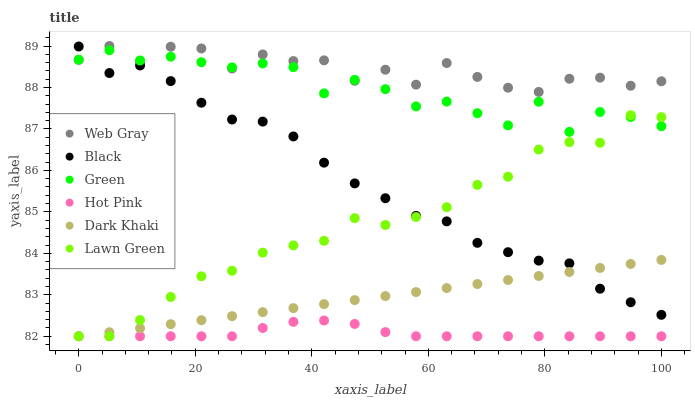Does Hot Pink have the minimum area under the curve?
Answer yes or no. Yes. Does Web Gray have the maximum area under the curve?
Answer yes or no. Yes. Does Web Gray have the minimum area under the curve?
Answer yes or no. No. Does Hot Pink have the maximum area under the curve?
Answer yes or no. No. Is Dark Khaki the smoothest?
Answer yes or no. Yes. Is Web Gray the roughest?
Answer yes or no. Yes. Is Hot Pink the smoothest?
Answer yes or no. No. Is Hot Pink the roughest?
Answer yes or no. No. Does Lawn Green have the lowest value?
Answer yes or no. Yes. Does Web Gray have the lowest value?
Answer yes or no. No. Does Web Gray have the highest value?
Answer yes or no. Yes. Does Hot Pink have the highest value?
Answer yes or no. No. Is Dark Khaki less than Green?
Answer yes or no. Yes. Is Green greater than Dark Khaki?
Answer yes or no. Yes. Does Dark Khaki intersect Black?
Answer yes or no. Yes. Is Dark Khaki less than Black?
Answer yes or no. No. Is Dark Khaki greater than Black?
Answer yes or no. No. Does Dark Khaki intersect Green?
Answer yes or no. No. 